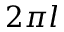<formula> <loc_0><loc_0><loc_500><loc_500>2 \pi l</formula> 